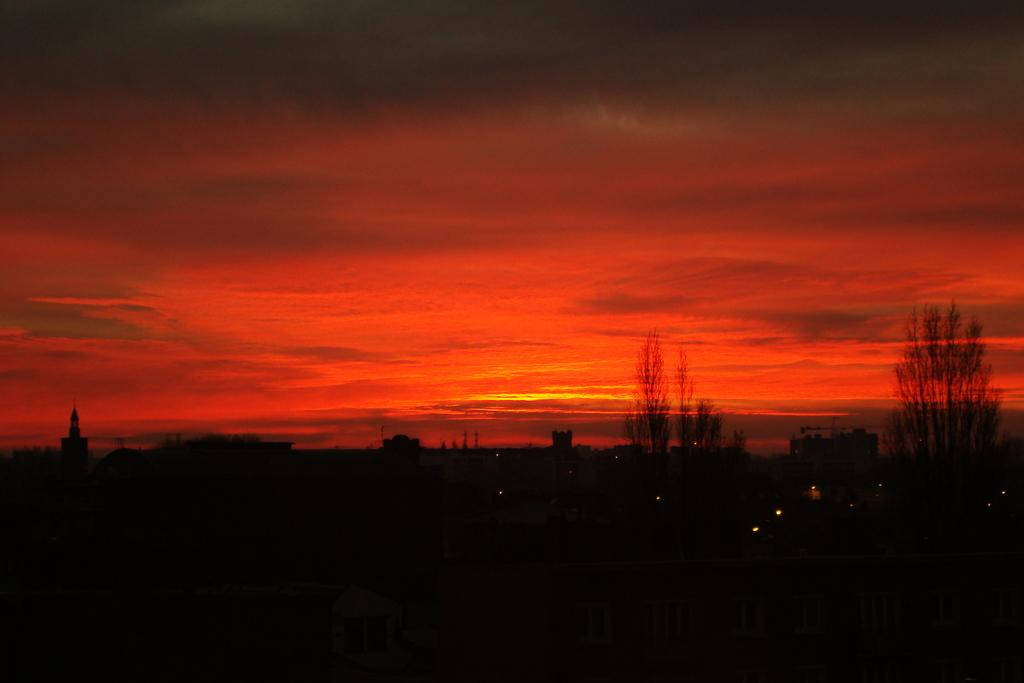What type of structures can be seen in the image? There are buildings in the image. What other natural elements are present in the image? There are trees in the image. What is the color of the sky in the image? The sky appears reddish in the image. How many feet of cabbage can be seen growing near the buildings in the image? There is no cabbage present in the image, so it is not possible to determine the number of feet of cabbage. 